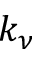<formula> <loc_0><loc_0><loc_500><loc_500>k _ { \nu }</formula> 